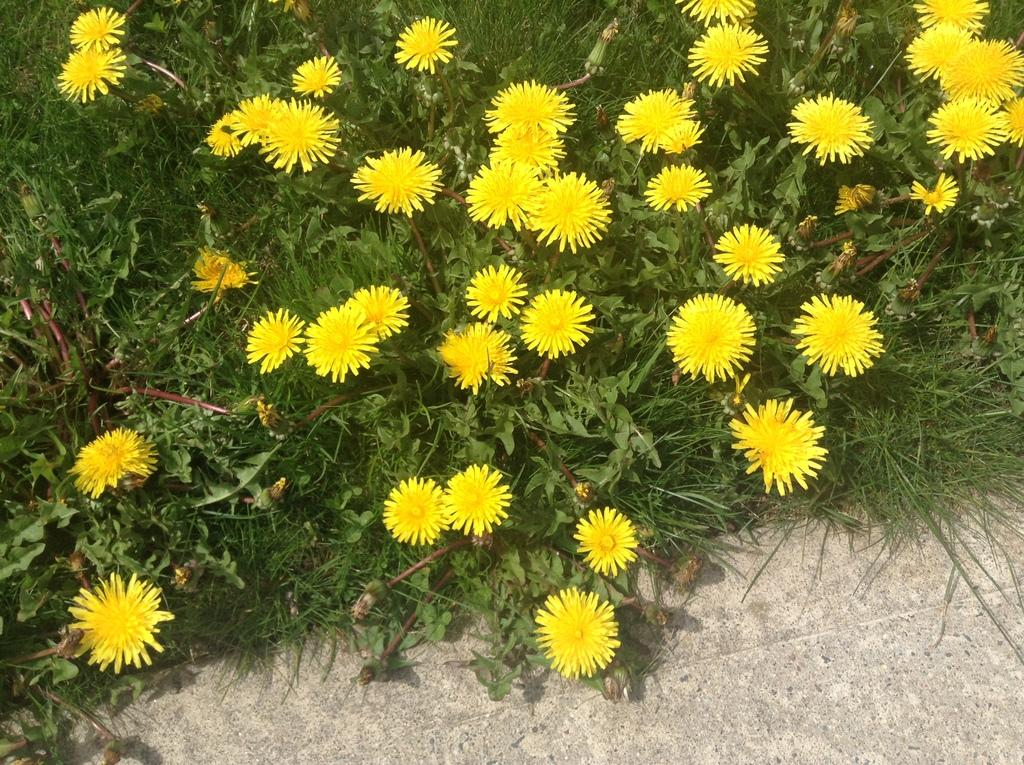What type of flowers can be seen on the plant in the image? There are yellow flowers on a plant in the image. What can be seen beneath the plant in the image? The ground is visible in the image. Where is the faucet located in the image? There is no faucet present in the image. What type of yak can be seen grazing in the background of the image? There is no yak present in the image. 